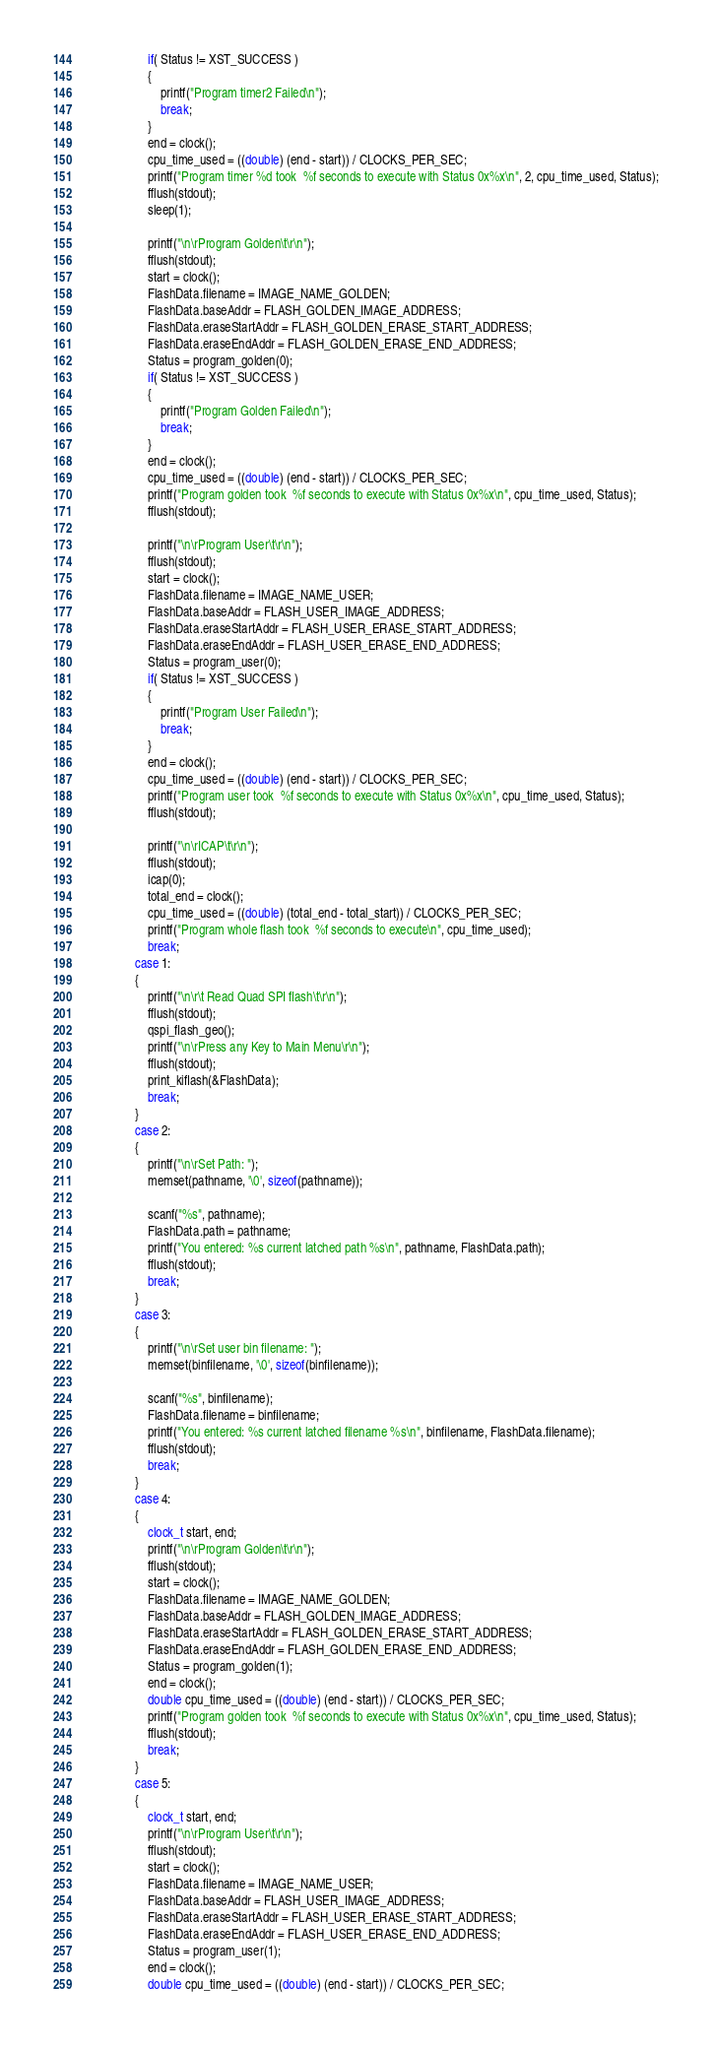<code> <loc_0><loc_0><loc_500><loc_500><_C_>					if( Status != XST_SUCCESS )
					{
						printf("Program timer2 Failed\n");						
						break;
					}						
					end = clock();
					cpu_time_used = ((double) (end - start)) / CLOCKS_PER_SEC;
					printf("Program timer %d took  %f seconds to execute with Status 0x%x\n", 2, cpu_time_used, Status); 
					fflush(stdout);
					sleep(1);

					printf("\n\rProgram Golden\t\r\n");
					fflush(stdout);						
					start = clock();
					FlashData.filename = IMAGE_NAME_GOLDEN;
					FlashData.baseAddr = FLASH_GOLDEN_IMAGE_ADDRESS;
					FlashData.eraseStartAddr = FLASH_GOLDEN_ERASE_START_ADDRESS;
					FlashData.eraseEndAddr = FLASH_GOLDEN_ERASE_END_ADDRESS;
					Status = program_golden(0);
					if( Status != XST_SUCCESS )
					{
						printf("Program Golden Failed\n");						
						break;
					}								
					end = clock();
					cpu_time_used = ((double) (end - start)) / CLOCKS_PER_SEC;
					printf("Program golden took  %f seconds to execute with Status 0x%x\n", cpu_time_used, Status); 
					fflush(stdout);

					printf("\n\rProgram User\t\r\n");					
					fflush(stdout);
					start = clock();
					FlashData.filename = IMAGE_NAME_USER;
					FlashData.baseAddr = FLASH_USER_IMAGE_ADDRESS;
					FlashData.eraseStartAddr = FLASH_USER_ERASE_START_ADDRESS;
					FlashData.eraseEndAddr = FLASH_USER_ERASE_END_ADDRESS;
					Status = program_user(0);
					if( Status != XST_SUCCESS )
					{
						printf("Program User Failed\n");						
						break;
					}						
					end = clock();
					cpu_time_used = ((double) (end - start)) / CLOCKS_PER_SEC;
					printf("Program user took  %f seconds to execute with Status 0x%x\n", cpu_time_used, Status); 
					fflush(stdout);

					printf("\n\rICAP\t\r\n");	
					fflush(stdout);
					icap(0);	
					total_end = clock();
					cpu_time_used = ((double) (total_end - total_start)) / CLOCKS_PER_SEC;
					printf("Program whole flash took  %f seconds to execute\n", cpu_time_used); 
					break;
				case 1:
				{
					printf("\n\r\t Read Quad SPI flash\t\r\n");
					fflush(stdout);
					qspi_flash_geo();
					printf("\n\rPress any Key to Main Menu\r\n");
					fflush(stdout);					
					print_kiflash(&FlashData);
					break;
				}
				case 2:
				{
					printf("\n\rSet Path: ");					
				   	memset(pathname, '\0', sizeof(pathname));
					
					scanf("%s", pathname);					
					FlashData.path = pathname;	
					printf("You entered: %s current latched path %s\n", pathname, FlashData.path);
					fflush(stdout);
					break;
				}
				case 3:
				{
					printf("\n\rSet user bin filename: ");					
				   	memset(binfilename, '\0', sizeof(binfilename));
					
					scanf("%s", binfilename);	
					FlashData.filename = binfilename;	
					printf("You entered: %s current latched filename %s\n", binfilename, FlashData.filename);
					fflush(stdout);				   	
					break;
				}				
				case 4:
				{ 
					clock_t start, end;					
					printf("\n\rProgram Golden\t\r\n");
					fflush(stdout);					
					start = clock();
					FlashData.filename = IMAGE_NAME_GOLDEN;
					FlashData.baseAddr = FLASH_GOLDEN_IMAGE_ADDRESS;
					FlashData.eraseStartAddr = FLASH_GOLDEN_ERASE_START_ADDRESS;
					FlashData.eraseEndAddr = FLASH_GOLDEN_ERASE_END_ADDRESS;
					Status = program_golden(1);
					end = clock();
					double cpu_time_used = ((double) (end - start)) / CLOCKS_PER_SEC;
					printf("Program golden took  %f seconds to execute with Status 0x%x\n", cpu_time_used, Status); 
					fflush(stdout);
					break;
				}		
				case 5:
				{
					clock_t start, end;					
					printf("\n\rProgram User\t\r\n");					
					fflush(stdout);
					start = clock();
					FlashData.filename = IMAGE_NAME_USER;
					FlashData.baseAddr = FLASH_USER_IMAGE_ADDRESS;
					FlashData.eraseStartAddr = FLASH_USER_ERASE_START_ADDRESS;
					FlashData.eraseEndAddr = FLASH_USER_ERASE_END_ADDRESS;
					Status = program_user(1);
					end = clock();
					double cpu_time_used = ((double) (end - start)) / CLOCKS_PER_SEC;</code> 